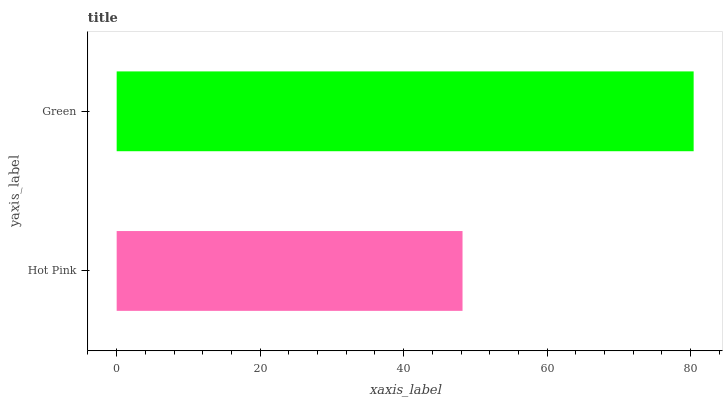Is Hot Pink the minimum?
Answer yes or no. Yes. Is Green the maximum?
Answer yes or no. Yes. Is Green the minimum?
Answer yes or no. No. Is Green greater than Hot Pink?
Answer yes or no. Yes. Is Hot Pink less than Green?
Answer yes or no. Yes. Is Hot Pink greater than Green?
Answer yes or no. No. Is Green less than Hot Pink?
Answer yes or no. No. Is Green the high median?
Answer yes or no. Yes. Is Hot Pink the low median?
Answer yes or no. Yes. Is Hot Pink the high median?
Answer yes or no. No. Is Green the low median?
Answer yes or no. No. 